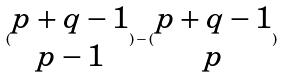Convert formula to latex. <formula><loc_0><loc_0><loc_500><loc_500>( \begin{matrix} p + q - 1 \\ p - 1 \end{matrix} ) - ( \begin{matrix} p + q - 1 \\ p \end{matrix} )</formula> 